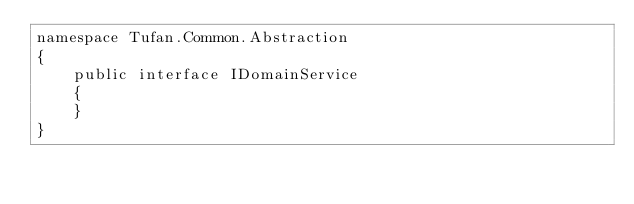Convert code to text. <code><loc_0><loc_0><loc_500><loc_500><_C#_>namespace Tufan.Common.Abstraction
{
    public interface IDomainService
    {
    }
}</code> 